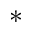<formula> <loc_0><loc_0><loc_500><loc_500>*</formula> 